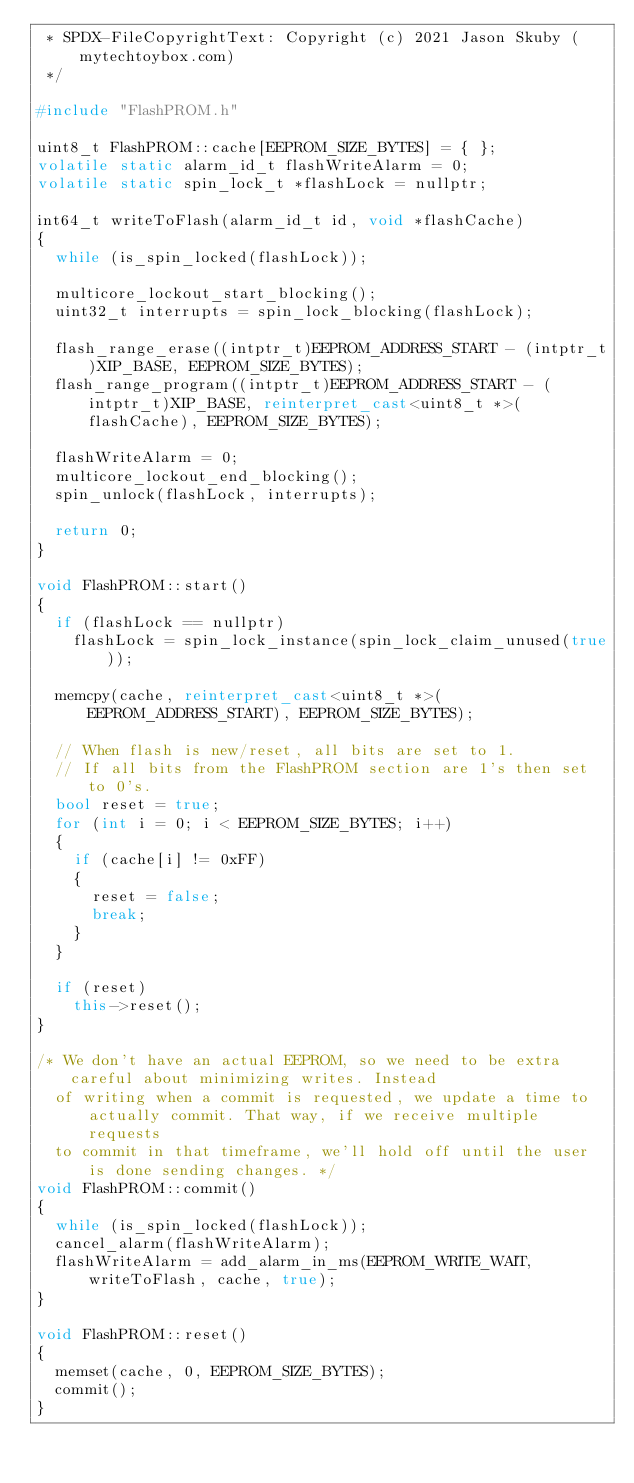<code> <loc_0><loc_0><loc_500><loc_500><_C++_> * SPDX-FileCopyrightText: Copyright (c) 2021 Jason Skuby (mytechtoybox.com)
 */

#include "FlashPROM.h"

uint8_t FlashPROM::cache[EEPROM_SIZE_BYTES] = { };
volatile static alarm_id_t flashWriteAlarm = 0;
volatile static spin_lock_t *flashLock = nullptr;

int64_t writeToFlash(alarm_id_t id, void *flashCache)
{
	while (is_spin_locked(flashLock));

	multicore_lockout_start_blocking();
	uint32_t interrupts = spin_lock_blocking(flashLock);

	flash_range_erase((intptr_t)EEPROM_ADDRESS_START - (intptr_t)XIP_BASE, EEPROM_SIZE_BYTES);
	flash_range_program((intptr_t)EEPROM_ADDRESS_START - (intptr_t)XIP_BASE, reinterpret_cast<uint8_t *>(flashCache), EEPROM_SIZE_BYTES);

	flashWriteAlarm = 0;
	multicore_lockout_end_blocking();
	spin_unlock(flashLock, interrupts);

	return 0;
}

void FlashPROM::start()
{
	if (flashLock == nullptr)
		flashLock = spin_lock_instance(spin_lock_claim_unused(true));

	memcpy(cache, reinterpret_cast<uint8_t *>(EEPROM_ADDRESS_START), EEPROM_SIZE_BYTES);

	// When flash is new/reset, all bits are set to 1.
	// If all bits from the FlashPROM section are 1's then set to 0's.
	bool reset = true;
	for (int i = 0; i < EEPROM_SIZE_BYTES; i++)
	{
		if (cache[i] != 0xFF)
		{
			reset = false;
			break;
		}
	}

	if (reset)
		this->reset();
}

/* We don't have an actual EEPROM, so we need to be extra careful about minimizing writes. Instead
	of writing when a commit is requested, we update a time to actually commit. That way, if we receive multiple requests
	to commit in that timeframe, we'll hold off until the user is done sending changes. */
void FlashPROM::commit()
{
	while (is_spin_locked(flashLock));
	cancel_alarm(flashWriteAlarm);
	flashWriteAlarm = add_alarm_in_ms(EEPROM_WRITE_WAIT, writeToFlash, cache, true);
}

void FlashPROM::reset()
{
	memset(cache, 0, EEPROM_SIZE_BYTES);
	commit();
}
</code> 